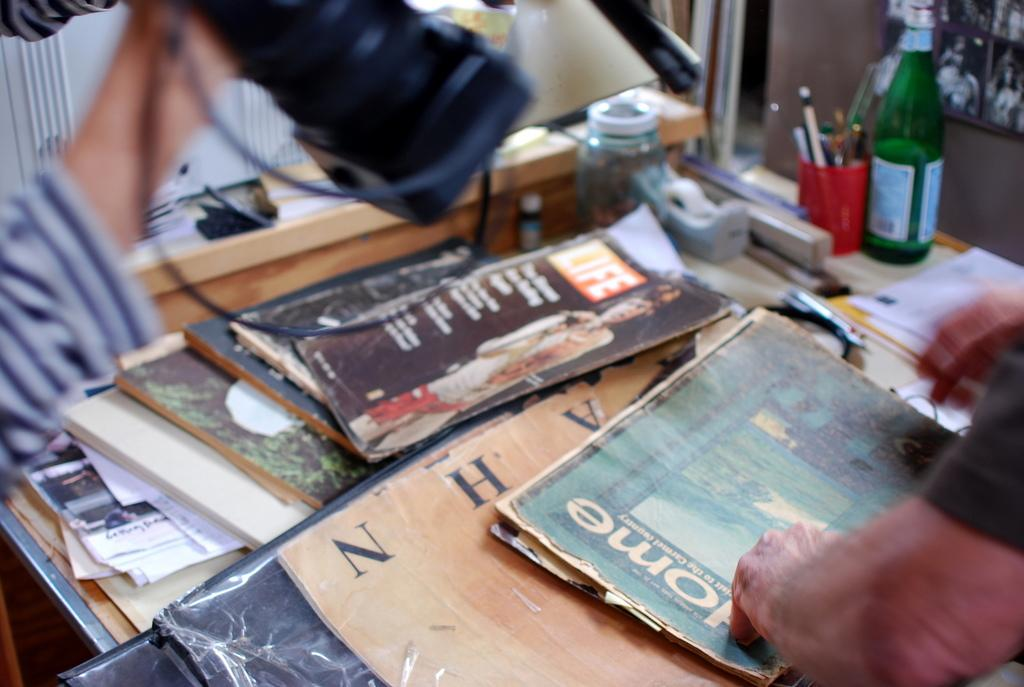<image>
Relay a brief, clear account of the picture shown. A man standing over a collection of magazines, one title Home. 